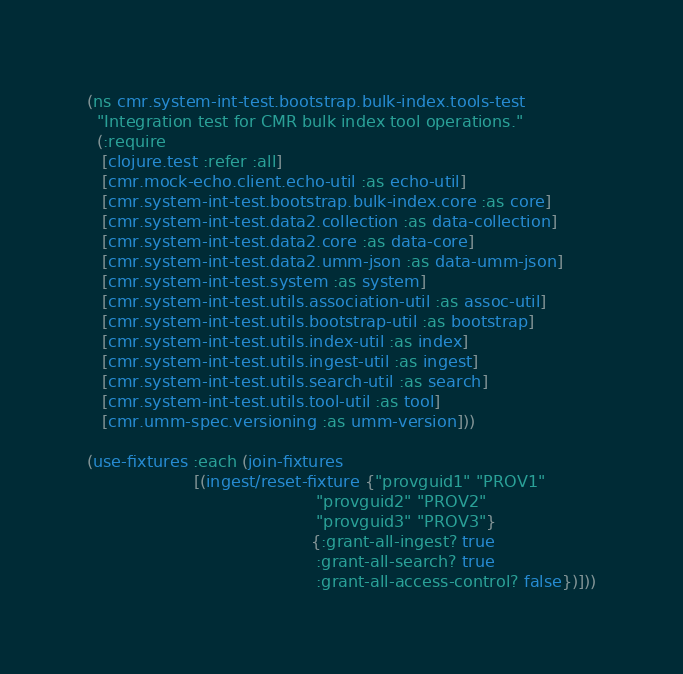Convert code to text. <code><loc_0><loc_0><loc_500><loc_500><_Clojure_>(ns cmr.system-int-test.bootstrap.bulk-index.tools-test
  "Integration test for CMR bulk index tool operations."
  (:require
   [clojure.test :refer :all]
   [cmr.mock-echo.client.echo-util :as echo-util]
   [cmr.system-int-test.bootstrap.bulk-index.core :as core]
   [cmr.system-int-test.data2.collection :as data-collection]
   [cmr.system-int-test.data2.core :as data-core]
   [cmr.system-int-test.data2.umm-json :as data-umm-json]
   [cmr.system-int-test.system :as system]
   [cmr.system-int-test.utils.association-util :as assoc-util]
   [cmr.system-int-test.utils.bootstrap-util :as bootstrap]
   [cmr.system-int-test.utils.index-util :as index]
   [cmr.system-int-test.utils.ingest-util :as ingest]
   [cmr.system-int-test.utils.search-util :as search]
   [cmr.system-int-test.utils.tool-util :as tool]
   [cmr.umm-spec.versioning :as umm-version]))

(use-fixtures :each (join-fixtures
                     [(ingest/reset-fixture {"provguid1" "PROV1"
                                             "provguid2" "PROV2"
                                             "provguid3" "PROV3"}
                                            {:grant-all-ingest? true
                                             :grant-all-search? true
                                             :grant-all-access-control? false})]))
</code> 